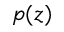Convert formula to latex. <formula><loc_0><loc_0><loc_500><loc_500>p ( z )</formula> 